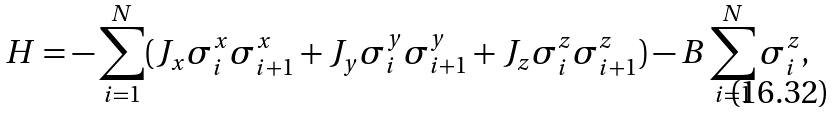<formula> <loc_0><loc_0><loc_500><loc_500>H = - \sum _ { i = 1 } ^ { N } ( J _ { x } \sigma _ { i } ^ { x } \sigma _ { i + 1 } ^ { x } + J _ { y } \sigma _ { i } ^ { y } \sigma _ { i + 1 } ^ { y } + J _ { z } \sigma _ { i } ^ { z } \sigma _ { i + 1 } ^ { z } ) - B \sum _ { i = 1 } ^ { N } \sigma ^ { z } _ { i } ,</formula> 